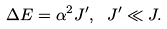<formula> <loc_0><loc_0><loc_500><loc_500>\Delta E = \alpha ^ { 2 } J ^ { \prime } , \ J ^ { \prime } \ll J .</formula> 